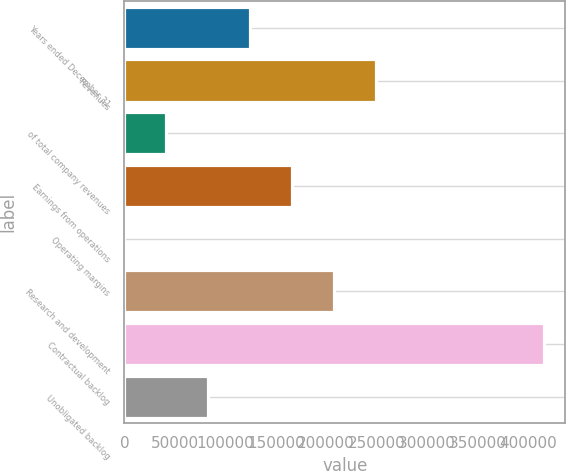<chart> <loc_0><loc_0><loc_500><loc_500><bar_chart><fcel>Years ended December 31<fcel>Revenues<fcel>of total company revenues<fcel>Earnings from operations<fcel>Operating margins<fcel>Research and development<fcel>Contractual backlog<fcel>Unobligated backlog<nl><fcel>124863<fcel>249721<fcel>41624.1<fcel>166482<fcel>4.8<fcel>208101<fcel>416198<fcel>83243.4<nl></chart> 